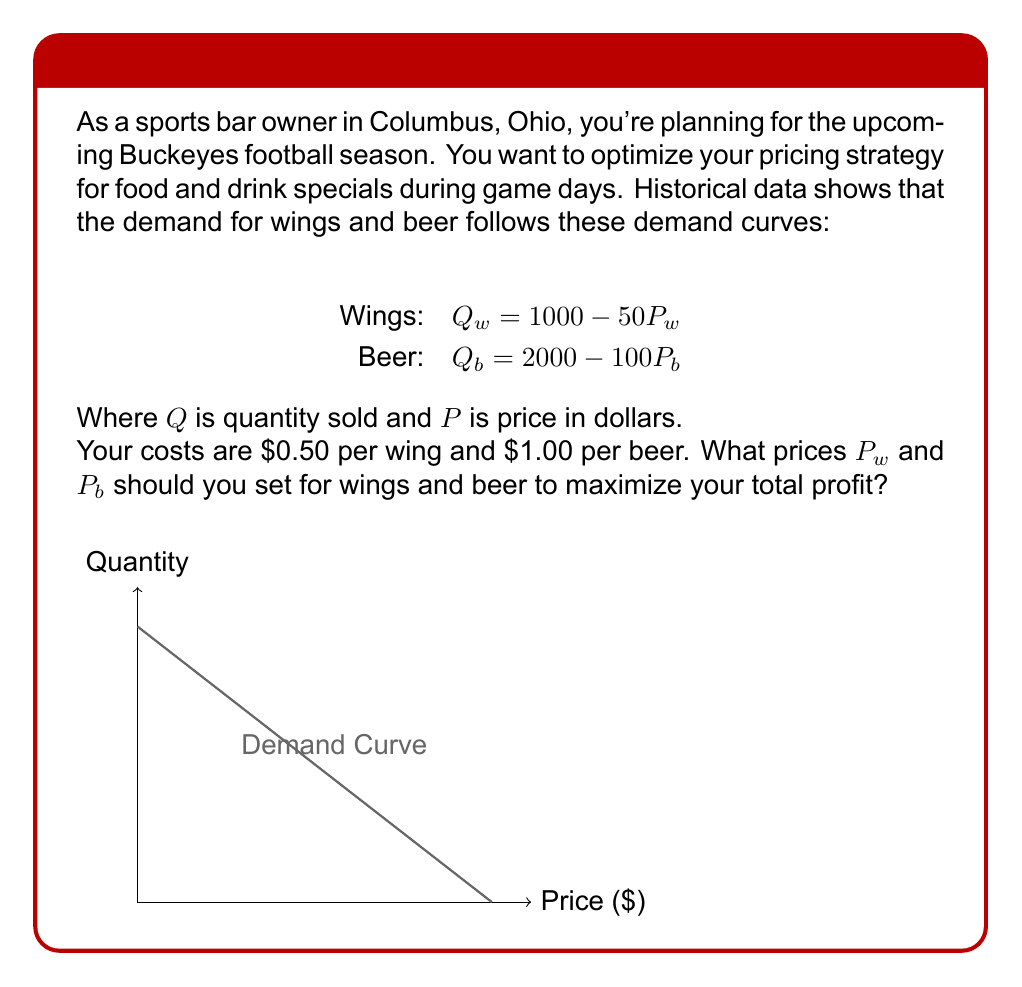Show me your answer to this math problem. Let's approach this step-by-step:

1) First, we need to express the profit functions for wings and beer:

   Profit = Revenue - Cost
   $\pi_w = P_w Q_w - 0.50Q_w = P_w(1000 - 50P_w) - 0.50(1000 - 50P_w)$
   $\pi_b = P_b Q_b - 1.00Q_b = P_b(2000 - 100P_b) - 1.00(2000 - 100P_b)$

2) Simplify these expressions:

   $\pi_w = 1000P_w - 50P_w^2 - 500 + 25P_w = -50P_w^2 + 1025P_w - 500$
   $\pi_b = 2000P_b - 100P_b^2 - 2000 + 100P_b = -100P_b^2 + 2100P_b - 2000$

3) To find the maximum profit, we need to find where the derivative of each profit function equals zero:

   $\frac{d\pi_w}{dP_w} = -100P_w + 1025 = 0$
   $\frac{d\pi_b}{dP_b} = -200P_b + 2100 = 0$

4) Solve these equations:

   $P_w = 10.25$
   $P_b = 10.50$

5) To confirm these are maxima, we can check the second derivatives are negative:

   $\frac{d^2\pi_w}{dP_w^2} = -100 < 0$
   $\frac{d^2\pi_b}{dP_b^2} = -200 < 0$

Therefore, these prices will maximize profit.
Answer: $P_w = \$10.25, P_b = \$10.50$ 